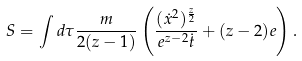<formula> <loc_0><loc_0><loc_500><loc_500>S = \int d \tau \frac { m } { 2 ( z - 1 ) } \left ( \frac { ( \dot { x } ^ { 2 } ) ^ { \frac { z } { 2 } } } { e ^ { z - 2 } \dot { t } } + ( z - 2 ) e \right ) .</formula> 